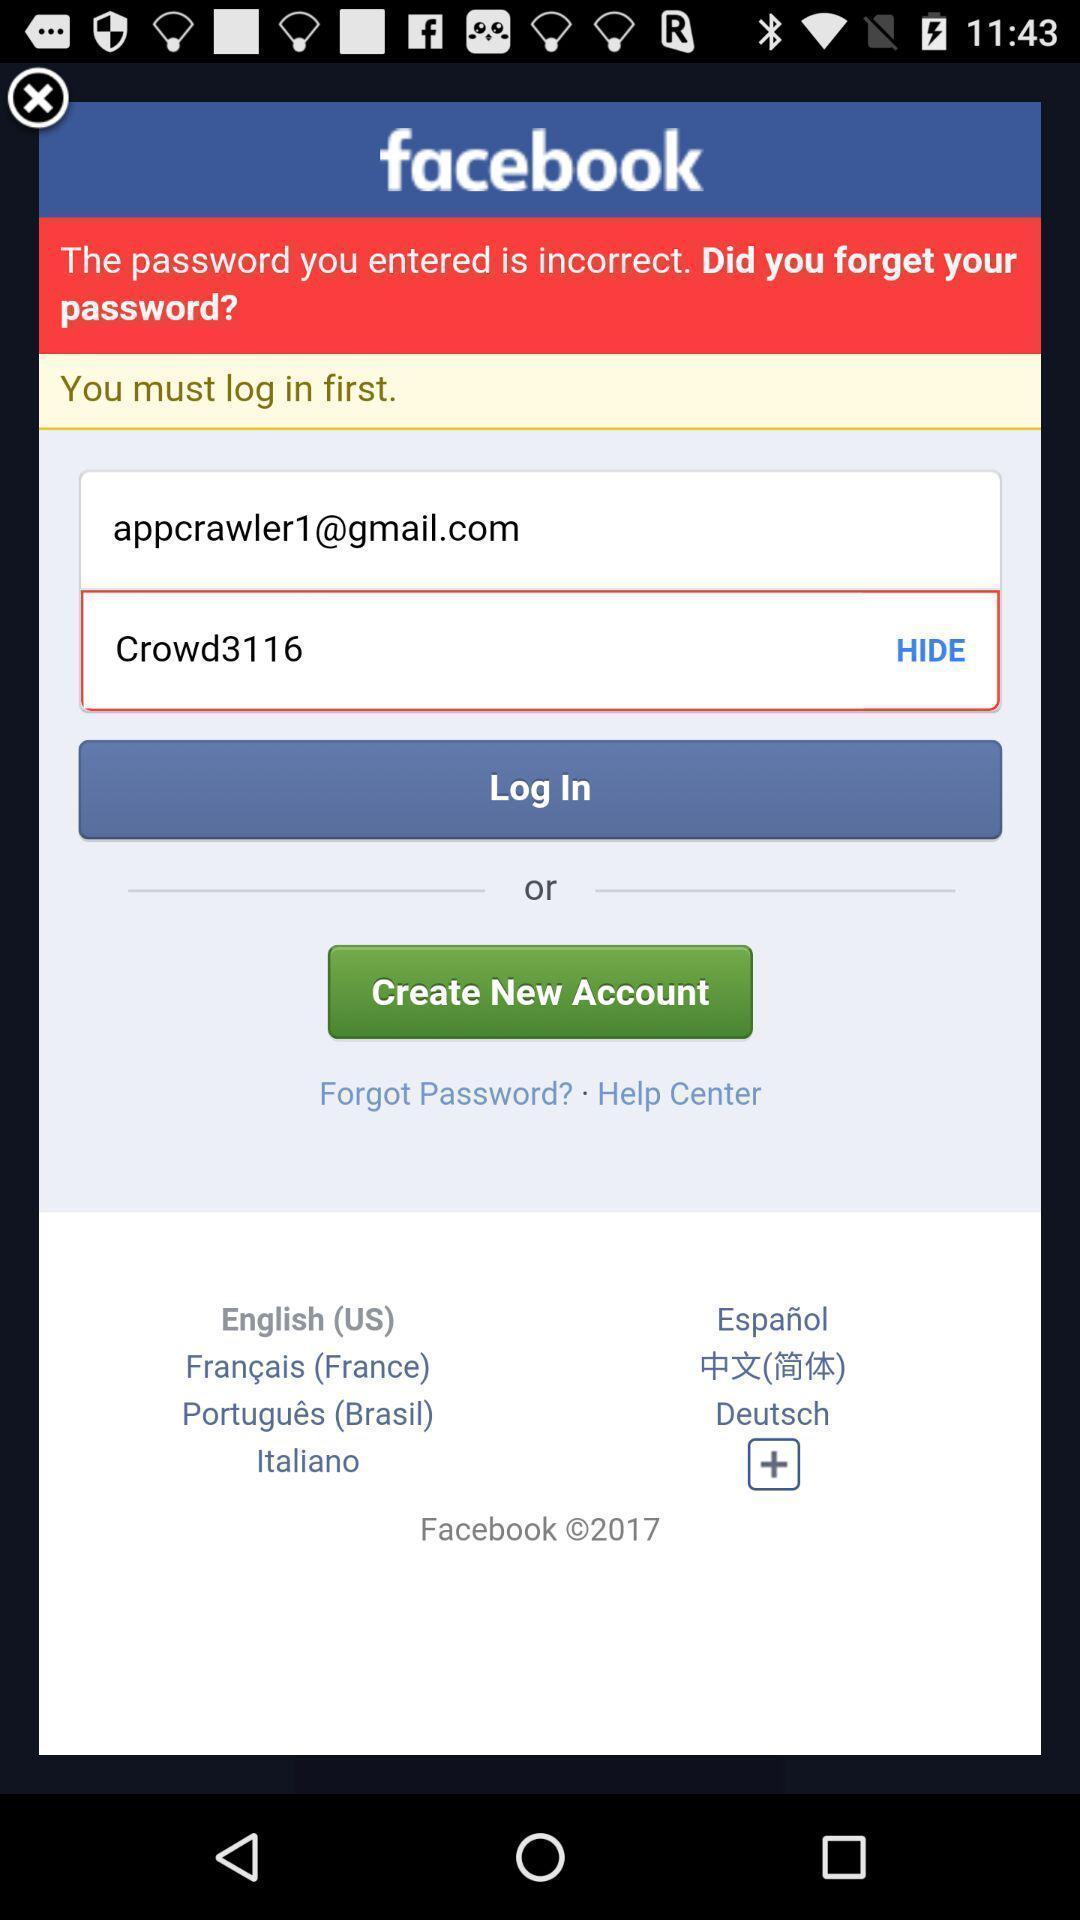What details can you identify in this image? Start page of a new account. 